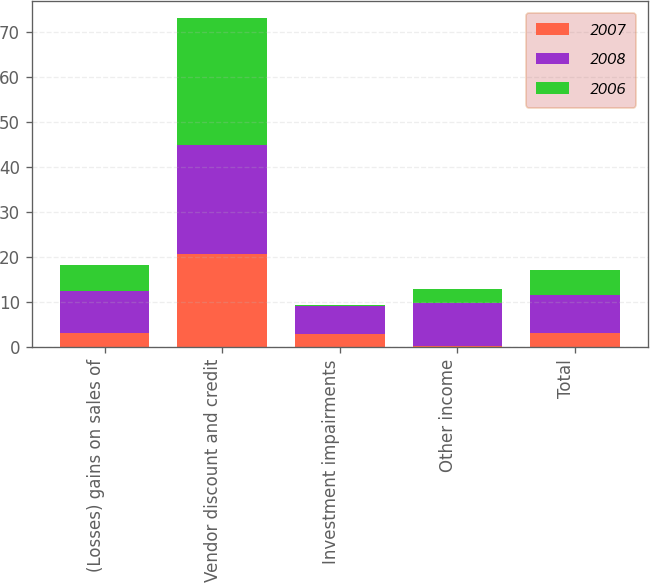<chart> <loc_0><loc_0><loc_500><loc_500><stacked_bar_chart><ecel><fcel>(Losses) gains on sales of<fcel>Vendor discount and credit<fcel>Investment impairments<fcel>Other income<fcel>Total<nl><fcel>2007<fcel>3.1<fcel>20.7<fcel>2.9<fcel>0.4<fcel>3.1<nl><fcel>2008<fcel>9.4<fcel>24.3<fcel>6.2<fcel>9.5<fcel>8.5<nl><fcel>2006<fcel>5.9<fcel>28.2<fcel>0.3<fcel>3.1<fcel>5.6<nl></chart> 